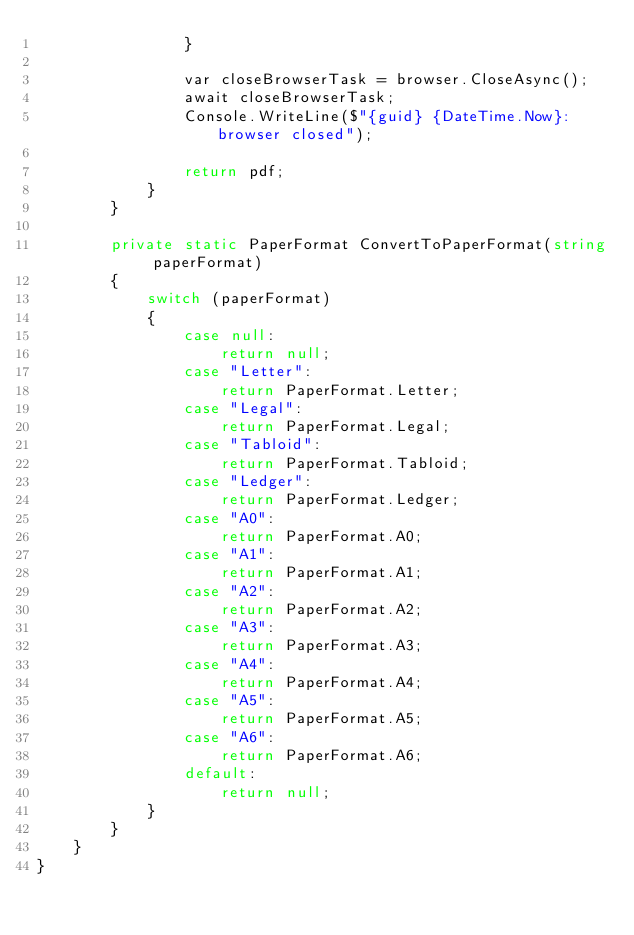Convert code to text. <code><loc_0><loc_0><loc_500><loc_500><_C#_>                }

                var closeBrowserTask = browser.CloseAsync();
                await closeBrowserTask;
                Console.WriteLine($"{guid} {DateTime.Now}: browser closed");
                
                return pdf;
            }
        }

        private static PaperFormat ConvertToPaperFormat(string paperFormat)
        {
            switch (paperFormat)
            {
                case null:
                    return null;
                case "Letter":
                    return PaperFormat.Letter;
                case "Legal":
                    return PaperFormat.Legal;
                case "Tabloid":
                    return PaperFormat.Tabloid;
                case "Ledger":
                    return PaperFormat.Ledger;
                case "A0":
                    return PaperFormat.A0;
                case "A1":
                    return PaperFormat.A1;
                case "A2":
                    return PaperFormat.A2;
                case "A3":
                    return PaperFormat.A3;
                case "A4":
                    return PaperFormat.A4;
                case "A5":
                    return PaperFormat.A5;
                case "A6":
                    return PaperFormat.A6;
                default:
                    return null;
            }
        }
    }
}</code> 